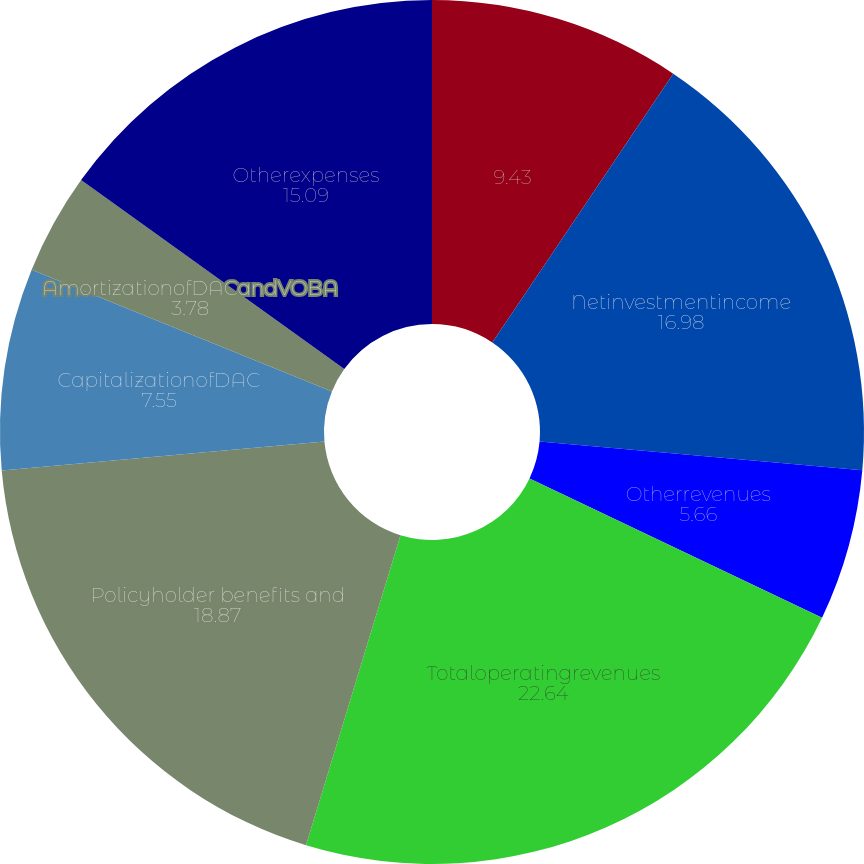Convert chart. <chart><loc_0><loc_0><loc_500><loc_500><pie_chart><ecel><fcel>Netinvestmentincome<fcel>Otherrevenues<fcel>Totaloperatingrevenues<fcel>Policyholder benefits and<fcel>CapitalizationofDAC<fcel>AmortizationofDACandVOBA<fcel>Interestexpense<fcel>Otherexpenses<nl><fcel>9.43%<fcel>16.98%<fcel>5.66%<fcel>22.64%<fcel>18.87%<fcel>7.55%<fcel>3.78%<fcel>0.0%<fcel>15.09%<nl></chart> 